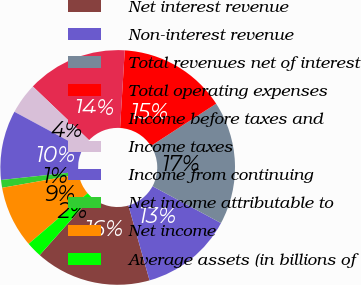Convert chart to OTSL. <chart><loc_0><loc_0><loc_500><loc_500><pie_chart><fcel>Net interest revenue<fcel>Non-interest revenue<fcel>Total revenues net of interest<fcel>Total operating expenses<fcel>Income before taxes and<fcel>Income taxes<fcel>Income from continuing<fcel>Net income attributable to<fcel>Net income<fcel>Average assets (in billions of<nl><fcel>15.95%<fcel>12.76%<fcel>17.01%<fcel>14.89%<fcel>13.83%<fcel>4.26%<fcel>9.57%<fcel>1.07%<fcel>8.51%<fcel>2.14%<nl></chart> 